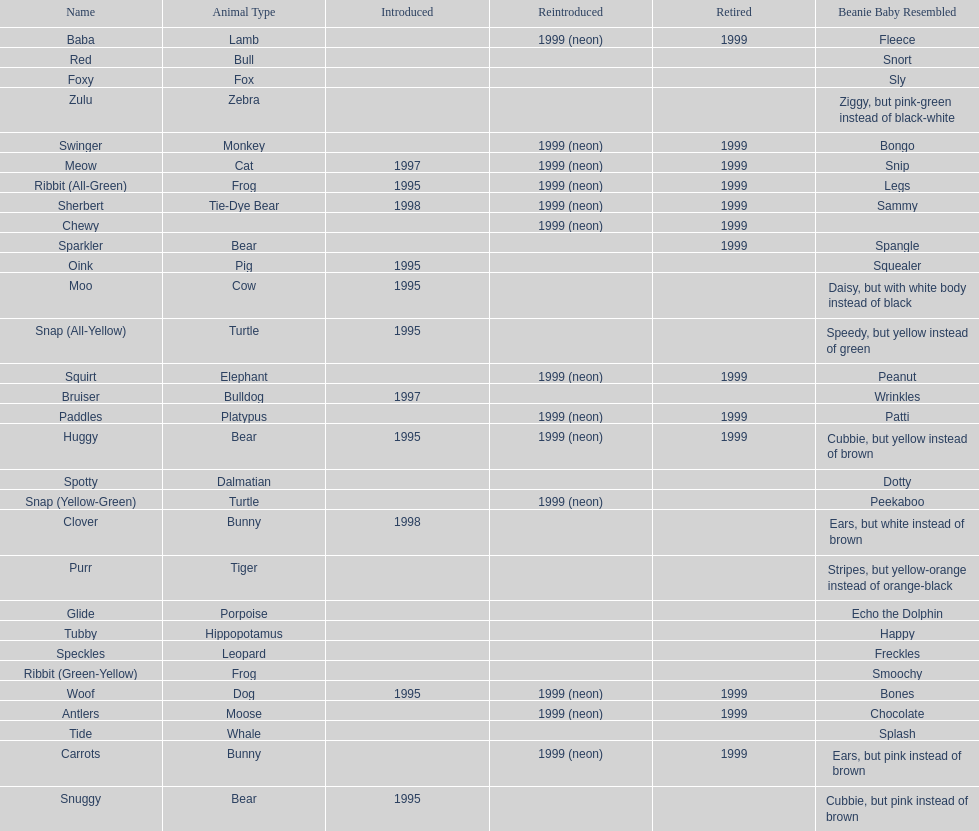Name the only pillow pal that is a dalmatian. Spotty. 